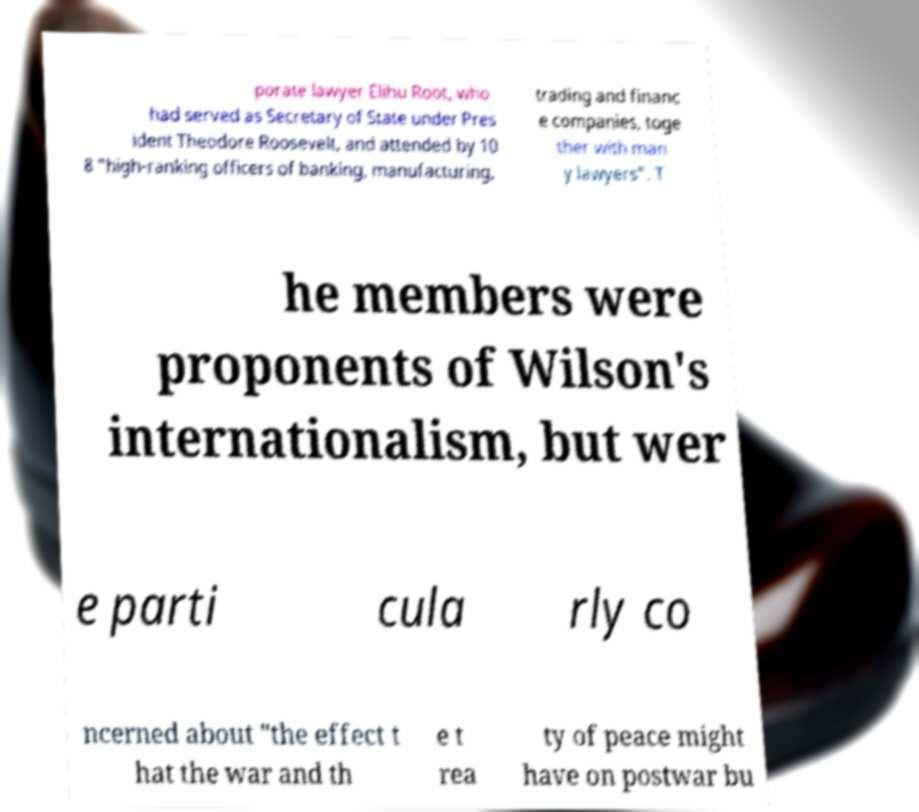What messages or text are displayed in this image? I need them in a readable, typed format. porate lawyer Elihu Root, who had served as Secretary of State under Pres ident Theodore Roosevelt, and attended by 10 8 "high-ranking officers of banking, manufacturing, trading and financ e companies, toge ther with man y lawyers". T he members were proponents of Wilson's internationalism, but wer e parti cula rly co ncerned about "the effect t hat the war and th e t rea ty of peace might have on postwar bu 